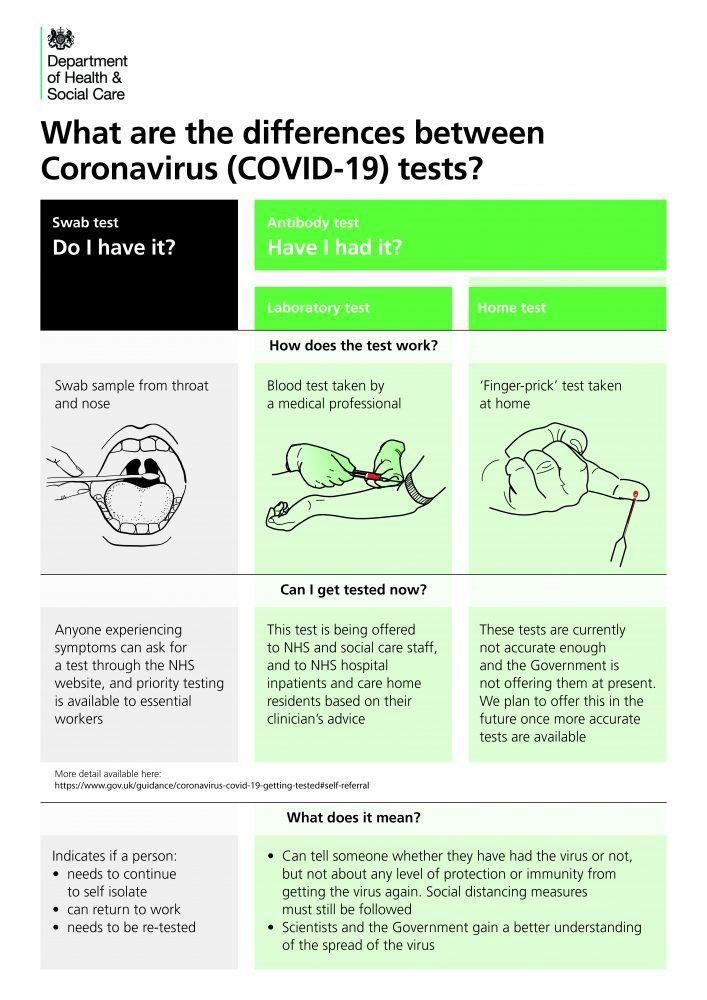What are the two types of coronavirus tests?
Answer the question with a short phrase. Swab test, antibody test Whose advice is required for conducting a laboratory test? Clinician's advice Through which website can one request for a swab test? NHS website Which test can be requested for through the NHS website? Swab test Which test is offered based on a clinicians advice? Laboratory test What are the two ways in which antibody testing can be done? Laboratory test, home test Which antibody test is inaccurate? Home test Which test indicates if a person needs to be isolated or can return to work? Swab test From where is a swab sample taken? Throat and nose Which antibody test involves blood testing by a medical professional? Laboratory test Who can ask for a swab test? Anyone experiencing symptoms Which test helps the scientists & government get a better understanding of the spread of the virus - swab test, antibody test or eye test? Antibody test Which antibody test involves finger prick testing? Home test Which test is not being provided by the government at present? Home test 